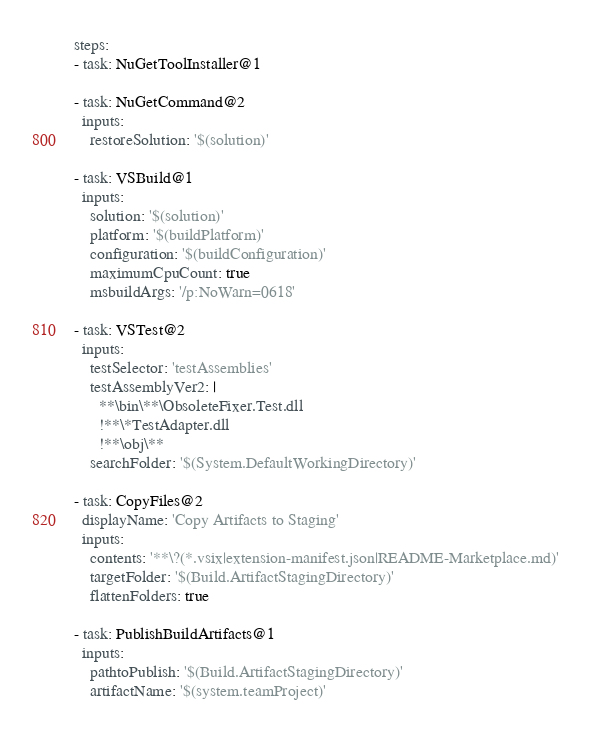<code> <loc_0><loc_0><loc_500><loc_500><_YAML_>
steps:
- task: NuGetToolInstaller@1

- task: NuGetCommand@2
  inputs:
    restoreSolution: '$(solution)'

- task: VSBuild@1
  inputs:
    solution: '$(solution)'
    platform: '$(buildPlatform)'
    configuration: '$(buildConfiguration)'
    maximumCpuCount: true
    msbuildArgs: '/p:NoWarn=0618'

- task: VSTest@2
  inputs:
    testSelector: 'testAssemblies'
    testAssemblyVer2: |
      **\bin\**\ObsoleteFixer.Test.dll
      !**\*TestAdapter.dll
      !**\obj\**
    searchFolder: '$(System.DefaultWorkingDirectory)'

- task: CopyFiles@2
  displayName: 'Copy Artifacts to Staging'
  inputs: 
    contents: '**\?(*.vsix|extension-manifest.json|README-Marketplace.md)'
    targetFolder: '$(Build.ArtifactStagingDirectory)'
    flattenFolders: true

- task: PublishBuildArtifacts@1
  inputs:
    pathtoPublish: '$(Build.ArtifactStagingDirectory)' 
    artifactName: '$(system.teamProject)'</code> 